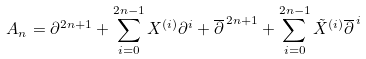<formula> <loc_0><loc_0><loc_500><loc_500>A _ { n } = \partial ^ { 2 n + 1 } + \sum _ { i = 0 } ^ { 2 n - 1 } X ^ { ( i ) } \partial ^ { i } + \overline { \partial } ^ { \, 2 n + 1 } + \sum _ { i = 0 } ^ { 2 n - 1 } \tilde { X } ^ { ( i ) } \overline { \partial } ^ { \, i }</formula> 